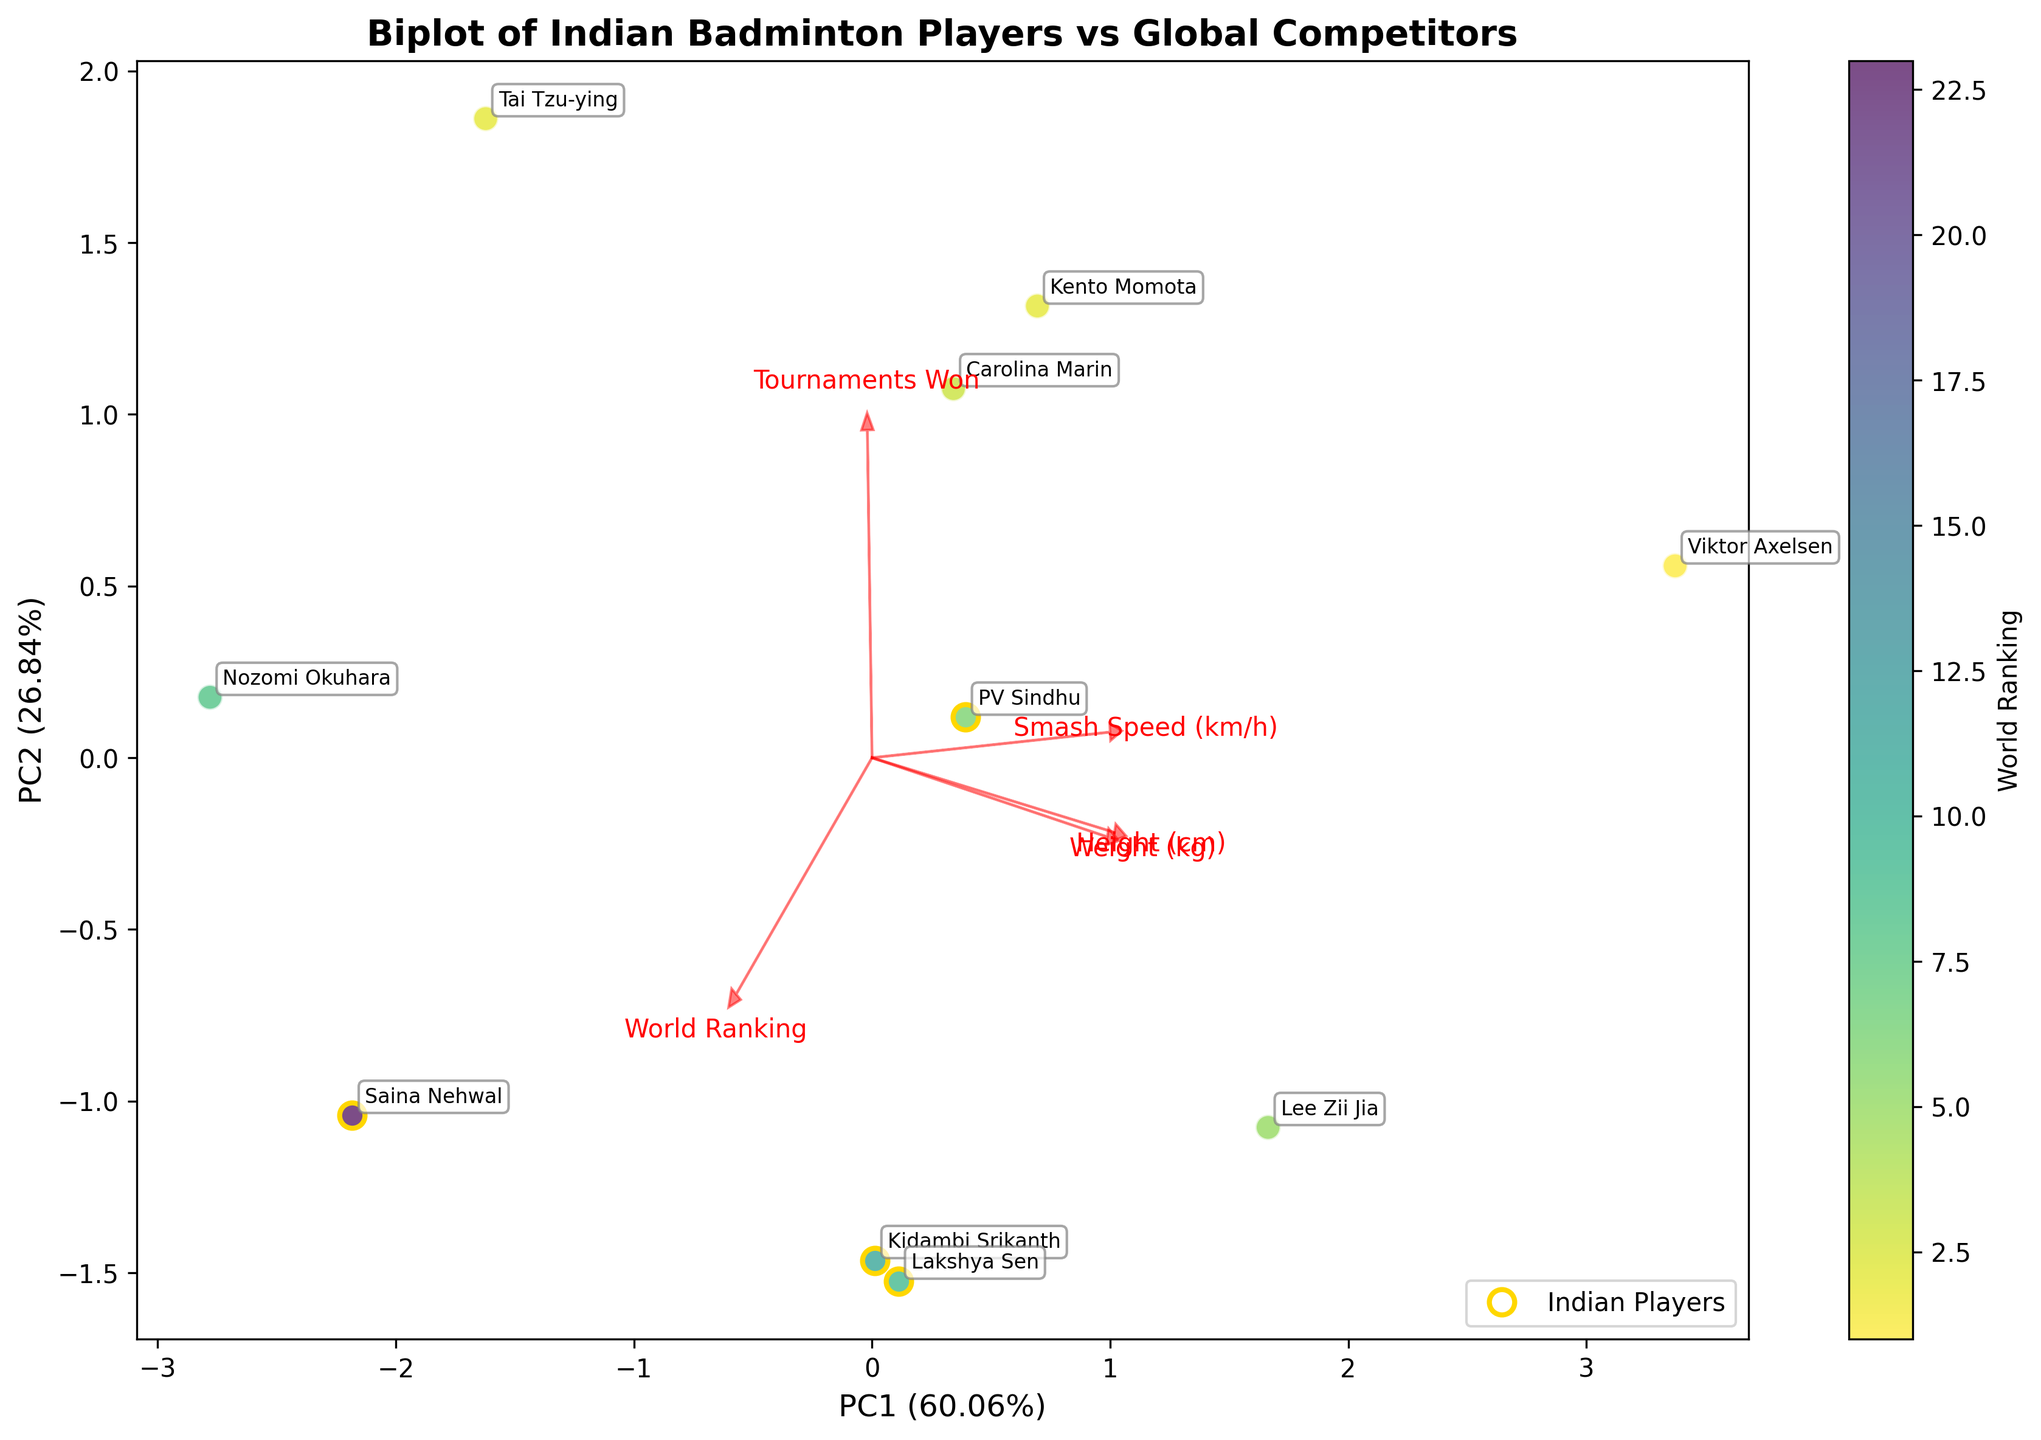What is the title of the biplot? The title of the biplot is usually displayed at the top of the figure. In this case, it is clearly mentioned at the top center in bold font.
Answer: Biplot of Indian Badminton Players vs Global Competitors How many Indian players are represented in the biplot? Indian players are highlighted with gold circles on the biplot. By counting these circles, we can determine the number of Indian players.
Answer: 4 What is the function of the arrows in the biplot? The arrows represent the loadings of the features on the principal components. Each arrow shows the direction and magnitude of the original variables.
Answer: Represent feature loadings Which player has the highest World Ranking according to the color scale? The color bar on the right side of the plot allows us to identify the World Ranking by color, with lower rankings having lighter colors. Viktor Axelsen has the highest World Ranking (1) and is represented by the lightest color.
Answer: Viktor Axelsen How are PV Sindhu and Saina Nehwal positioned in relation to each other in the biplot? By looking at the positions of PV Sindhu and Saina Nehwal, we can see that PV Sindhu is located towards the top-left and Saina Nehwal towards the bottom-right, indicating their different positions on the principal components.
Answer: PV Sindhu is top-left of Saina Nehwal Which direction does the Smash Speed variable point towards? The arrow for the Smash Speed variable indicates its direction. By observing the direction of this arrow, we can see it points downward and to the right.
Answer: Downward-right Who has the highest Smash Speed among the Indian players? By looking at the player annotations and their positions relative to the Smash Speed arrow, we can identify which Indian player is closest in that direction.
Answer: PV Sindhu Which players are closest to the Weight variable in the biplot? The players positioned nearest to the Weight variable's arrow are closest to this variable. We can determine this by observing the proximity of players to the arrow direction.
Answer: Viktor Axelsen, Lee Zii Jia Considering PC1 and PC2, which Indian player has the most balanced attributes according to the plot? A balanced player would be positioned near the center of the plot on both PC1 and PC2. By examining the positions of Indian players, we can identify who is closest to the center.
Answer: Kidambi Srikanth Which non-Indian player is most similar to PV Sindhu in terms of the principal components? By comparing the positions of non-Indian players to PV Sindhu, we can see which player is closest to her on the biplot.
Answer: Lakshya Sen 